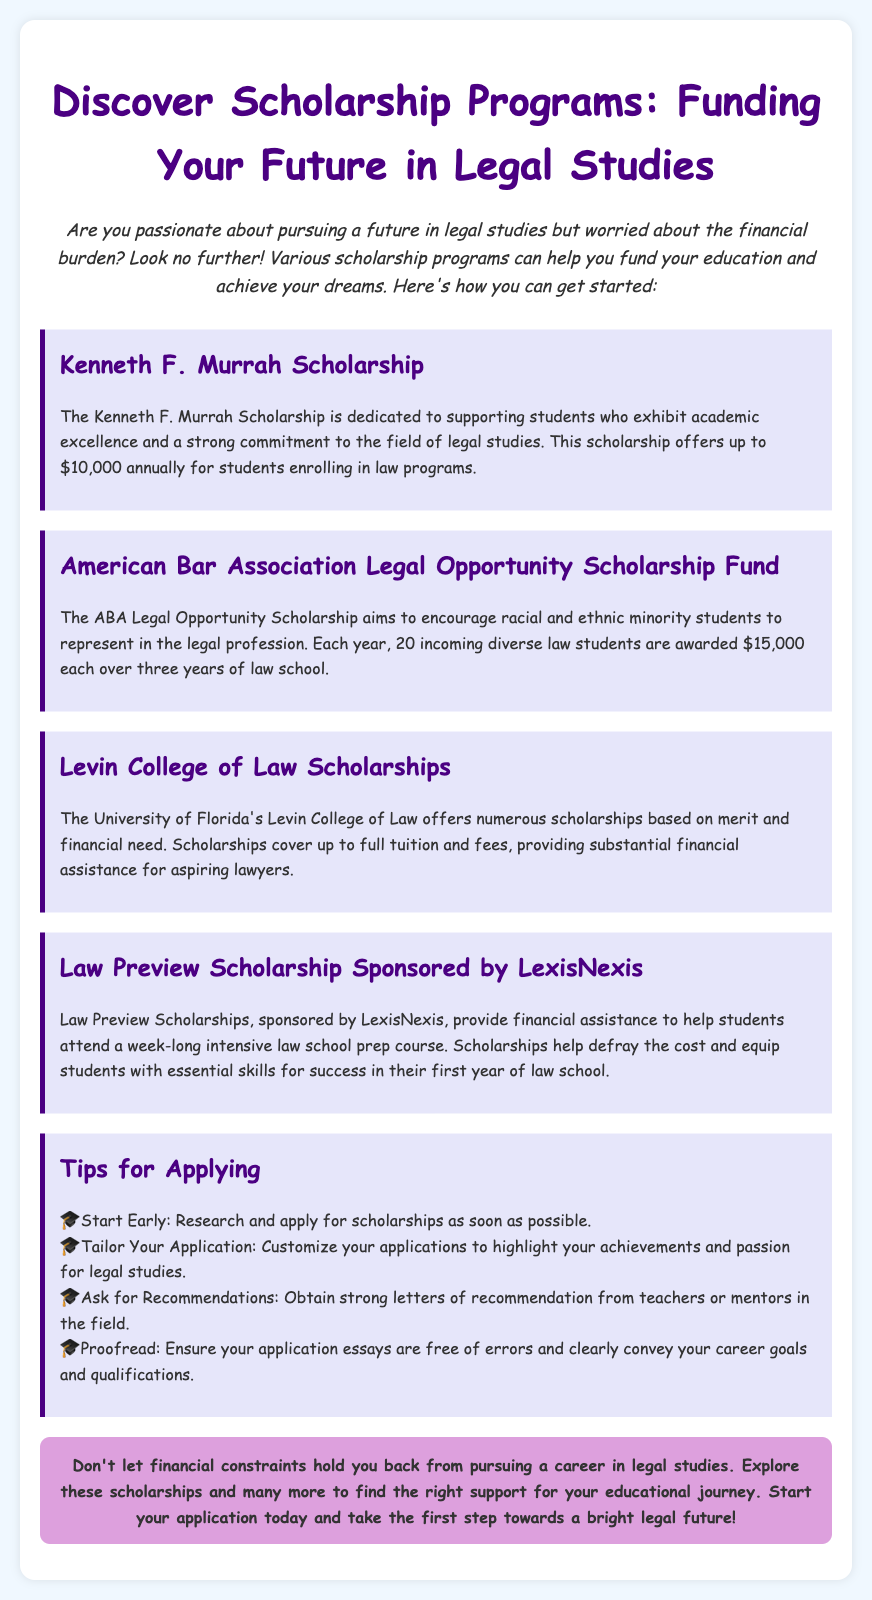What is the title of the advertisement? The title of the advertisement is prominently displayed at the top, indicating the main focus of the document.
Answer: Discover Scholarship Programs: Funding Your Future in Legal Studies How much can the Kenneth F. Murrah Scholarship award annually? The scholarship section provides specific monetary amounts associated with each scholarship, including the Kenneth F. Murrah Scholarship.
Answer: up to $10,000 Which organization provides the Legal Opportunity Scholarship Fund? The document mentions specific scholarships and their sponsoring organizations, including the one in question.
Answer: American Bar Association What are the two criteria for Levin College of Law Scholarships? The scholarship details include qualifying factors that determine eligibility for support among students.
Answer: merit and financial need How many students are awarded the ABA Legal Opportunity Scholarship each year? The section discussing the ABA scholarship states the number of students selected annually.
Answer: 20 What is a recommendation tip provided in the document? One section outlines essential tips for scholarship applications, including advice related to recommendations.
Answer: Ask for Recommendations What is the purpose of Law Preview Scholarships? The document describes the context and reason for offering these scholarships, focusing on preparation for law school.
Answer: financial assistance Who sponsors the Law Preview Scholarships? The document attributes sponsorship of a specific scholarship to a particular organization or company.
Answer: LexisNexis 